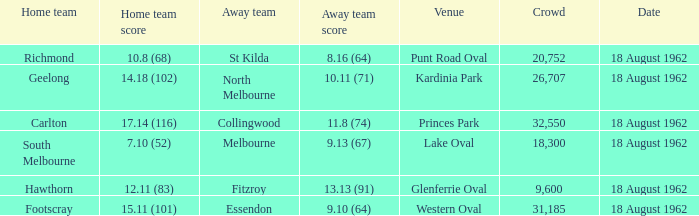What was the domestic team when the opponent team scored Footscray. 